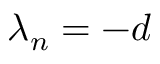Convert formula to latex. <formula><loc_0><loc_0><loc_500><loc_500>\lambda _ { n } = - d</formula> 